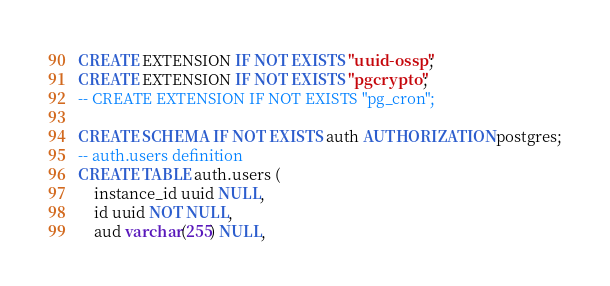Convert code to text. <code><loc_0><loc_0><loc_500><loc_500><_SQL_>CREATE EXTENSION IF NOT EXISTS "uuid-ossp";
CREATE EXTENSION IF NOT EXISTS "pgcrypto";
-- CREATE EXTENSION IF NOT EXISTS "pg_cron";

CREATE SCHEMA IF NOT EXISTS auth AUTHORIZATION postgres;
-- auth.users definition
CREATE TABLE auth.users (
	instance_id uuid NULL,
	id uuid NOT NULL,
	aud varchar(255) NULL,</code> 